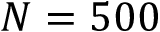Convert formula to latex. <formula><loc_0><loc_0><loc_500><loc_500>N = 5 0 0</formula> 